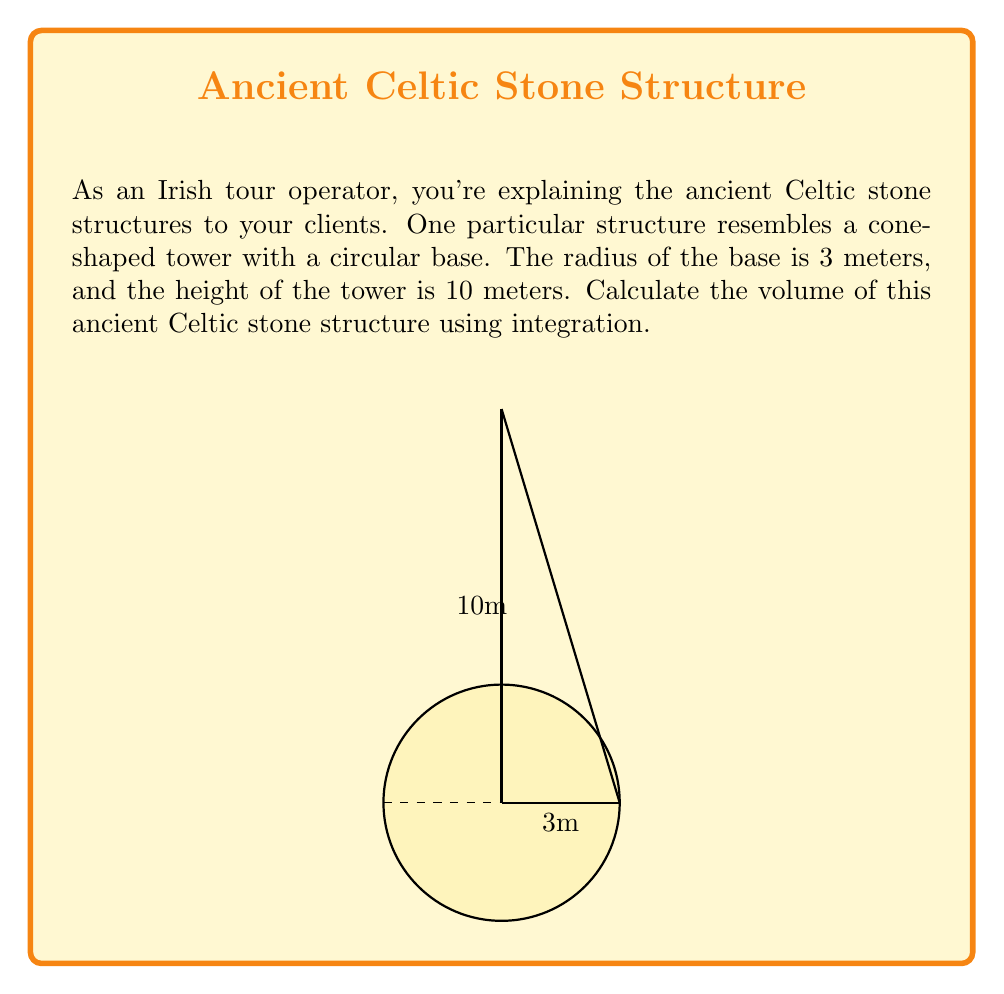Teach me how to tackle this problem. To calculate the volume of this cone-shaped structure, we'll use the method of integration by slicing.

1) First, let's set up our integral. The volume of a cone can be found by integrating the area of circular cross-sections from the base to the top.

2) The general formula for the volume of a solid of revolution is:

   $$V = \int_0^h \pi r(x)^2 dx$$

   where $r(x)$ is the radius at height $x$.

3) In a cone, the radius decreases linearly with height. We can express this as:

   $$r(x) = R(1 - \frac{x}{h})$$

   where $R$ is the base radius and $h$ is the height.

4) Substituting our values ($R=3$, $h=10$) and the expression for $r(x)$:

   $$V = \int_0^{10} \pi (3(1 - \frac{x}{10}))^2 dx$$

5) Simplify the integrand:

   $$V = \pi \int_0^{10} (3 - \frac{3x}{10})^2 dx = 9\pi \int_0^{10} (1 - \frac{x}{10})^2 dx$$

6) Expand the squared term:

   $$V = 9\pi \int_0^{10} (1 - \frac{2x}{10} + \frac{x^2}{100}) dx$$

7) Integrate term by term:

   $$V = 9\pi [\x - \frac{x^2}{10} + \frac{x^3}{300}]_0^{10}$$

8) Evaluate the integral:

   $$V = 9\pi [(10 - 10 + \frac{1000}{300}) - (0 - 0 + 0)]$$
   $$V = 9\pi [\frac{10}{3}] = 30\pi$$

9) Therefore, the volume is $30\pi$ cubic meters.
Answer: $30\pi$ m³ 